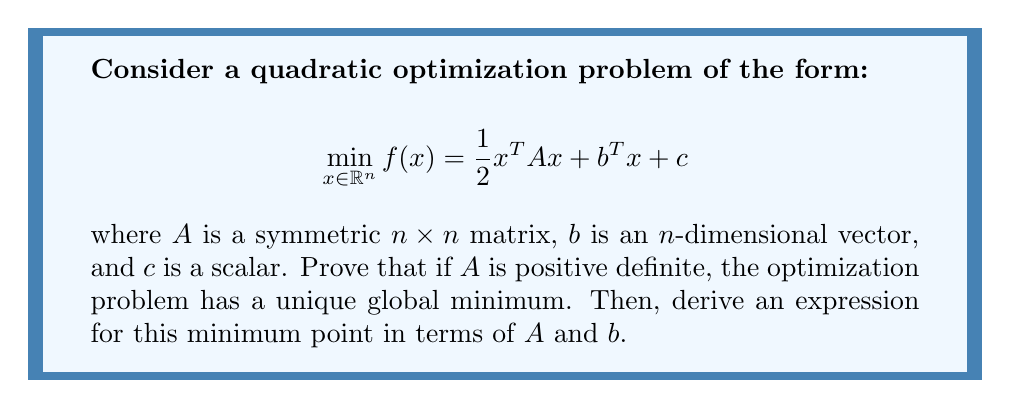Can you solve this math problem? To prove this and find the minimum point, we'll follow these steps:

1) First, let's recall the properties of positive definite matrices:
   - A symmetric matrix $A$ is positive definite if and only if $x^TAx > 0$ for all non-zero vectors $x$.
   - All eigenvalues of a positive definite matrix are strictly positive.
   - Positive definite matrices are invertible.

2) To find the critical points of $f(x)$, we need to find where its gradient equals zero:

   $$\nabla f(x) = Ax + b = 0$$

3) Since $A$ is positive definite, it's invertible. So we can solve for $x$:

   $$x = -A^{-1}b$$

4) To prove this critical point is a global minimum, we need to show the Hessian of $f(x)$ is positive definite:

   $$\nabla^2 f(x) = A$$

   We're given that $A$ is positive definite, so the Hessian is positive definite everywhere.

5) A function with a positive definite Hessian is strictly convex. A strictly convex function has at most one global minimum, and any critical point of a strictly convex function is its global minimum.

6) Therefore, $x = -A^{-1}b$ is the unique global minimum of $f(x)$.

This result showcases why positive definite matrices are crucial in optimization: they guarantee the existence and uniqueness of a global minimum in quadratic optimization problems, which are foundational in many areas of engineering and applied mathematics.
Answer: The unique global minimum point of the quadratic optimization problem is $x = -A^{-1}b$, where $A$ is the positive definite matrix and $b$ is the vector from the problem formulation. 